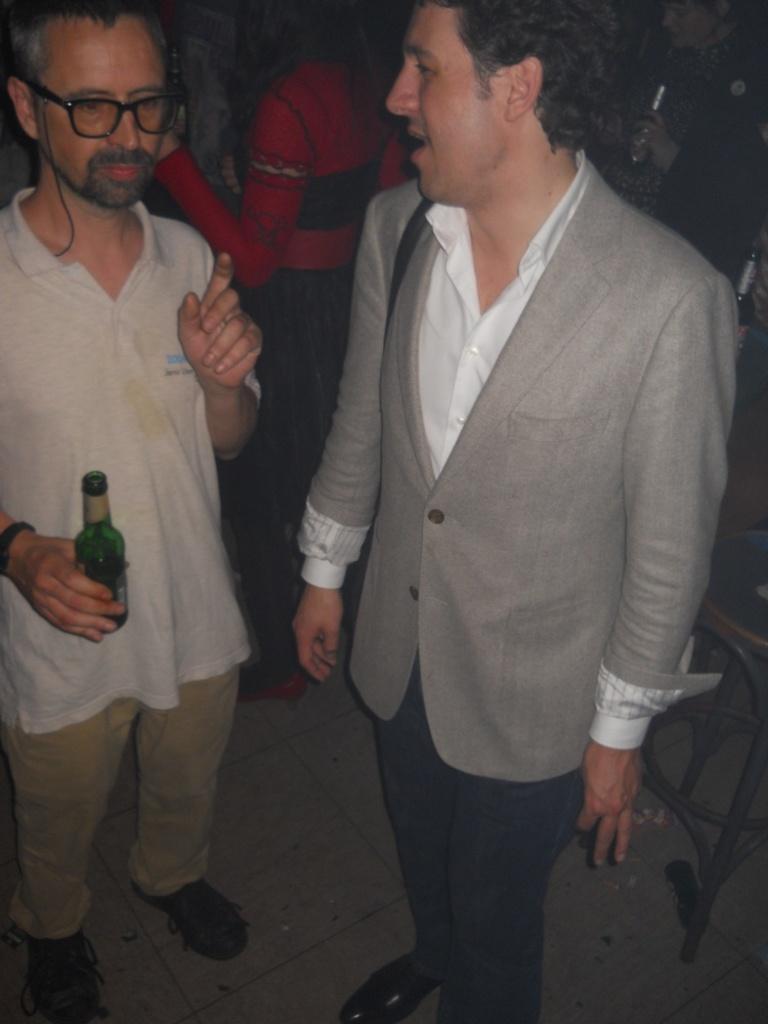Describe this image in one or two sentences. There are two men standing in this picture. One of the man who is wearing a spectacles is holding a bottle in his hand. 